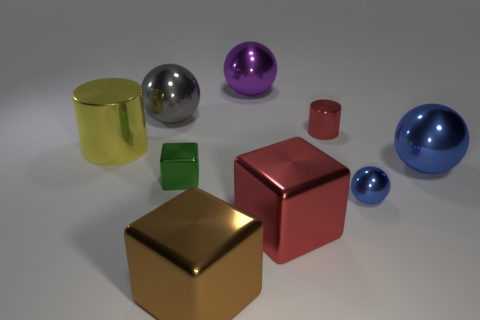What number of things are either cylinders that are behind the big cylinder or red blocks?
Provide a succinct answer. 2. What is the color of the small object that is the same shape as the large blue metallic object?
Provide a short and direct response. Blue. Is there anything else of the same color as the big metal cylinder?
Offer a very short reply. No. There is a metal cylinder that is on the right side of the big purple metallic thing; how big is it?
Keep it short and to the point. Small. Does the tiny ball have the same color as the large metallic sphere that is right of the purple shiny object?
Your answer should be very brief. Yes. How many other things are there of the same material as the small blue ball?
Provide a short and direct response. 8. Is the number of tiny red things greater than the number of tiny things?
Offer a terse response. No. There is a small object that is in front of the small block; does it have the same color as the small metal cylinder?
Offer a very short reply. No. The big cylinder is what color?
Ensure brevity in your answer.  Yellow. There is a small metal thing to the left of the purple metal thing; is there a big purple object that is on the left side of it?
Your answer should be compact. No. 